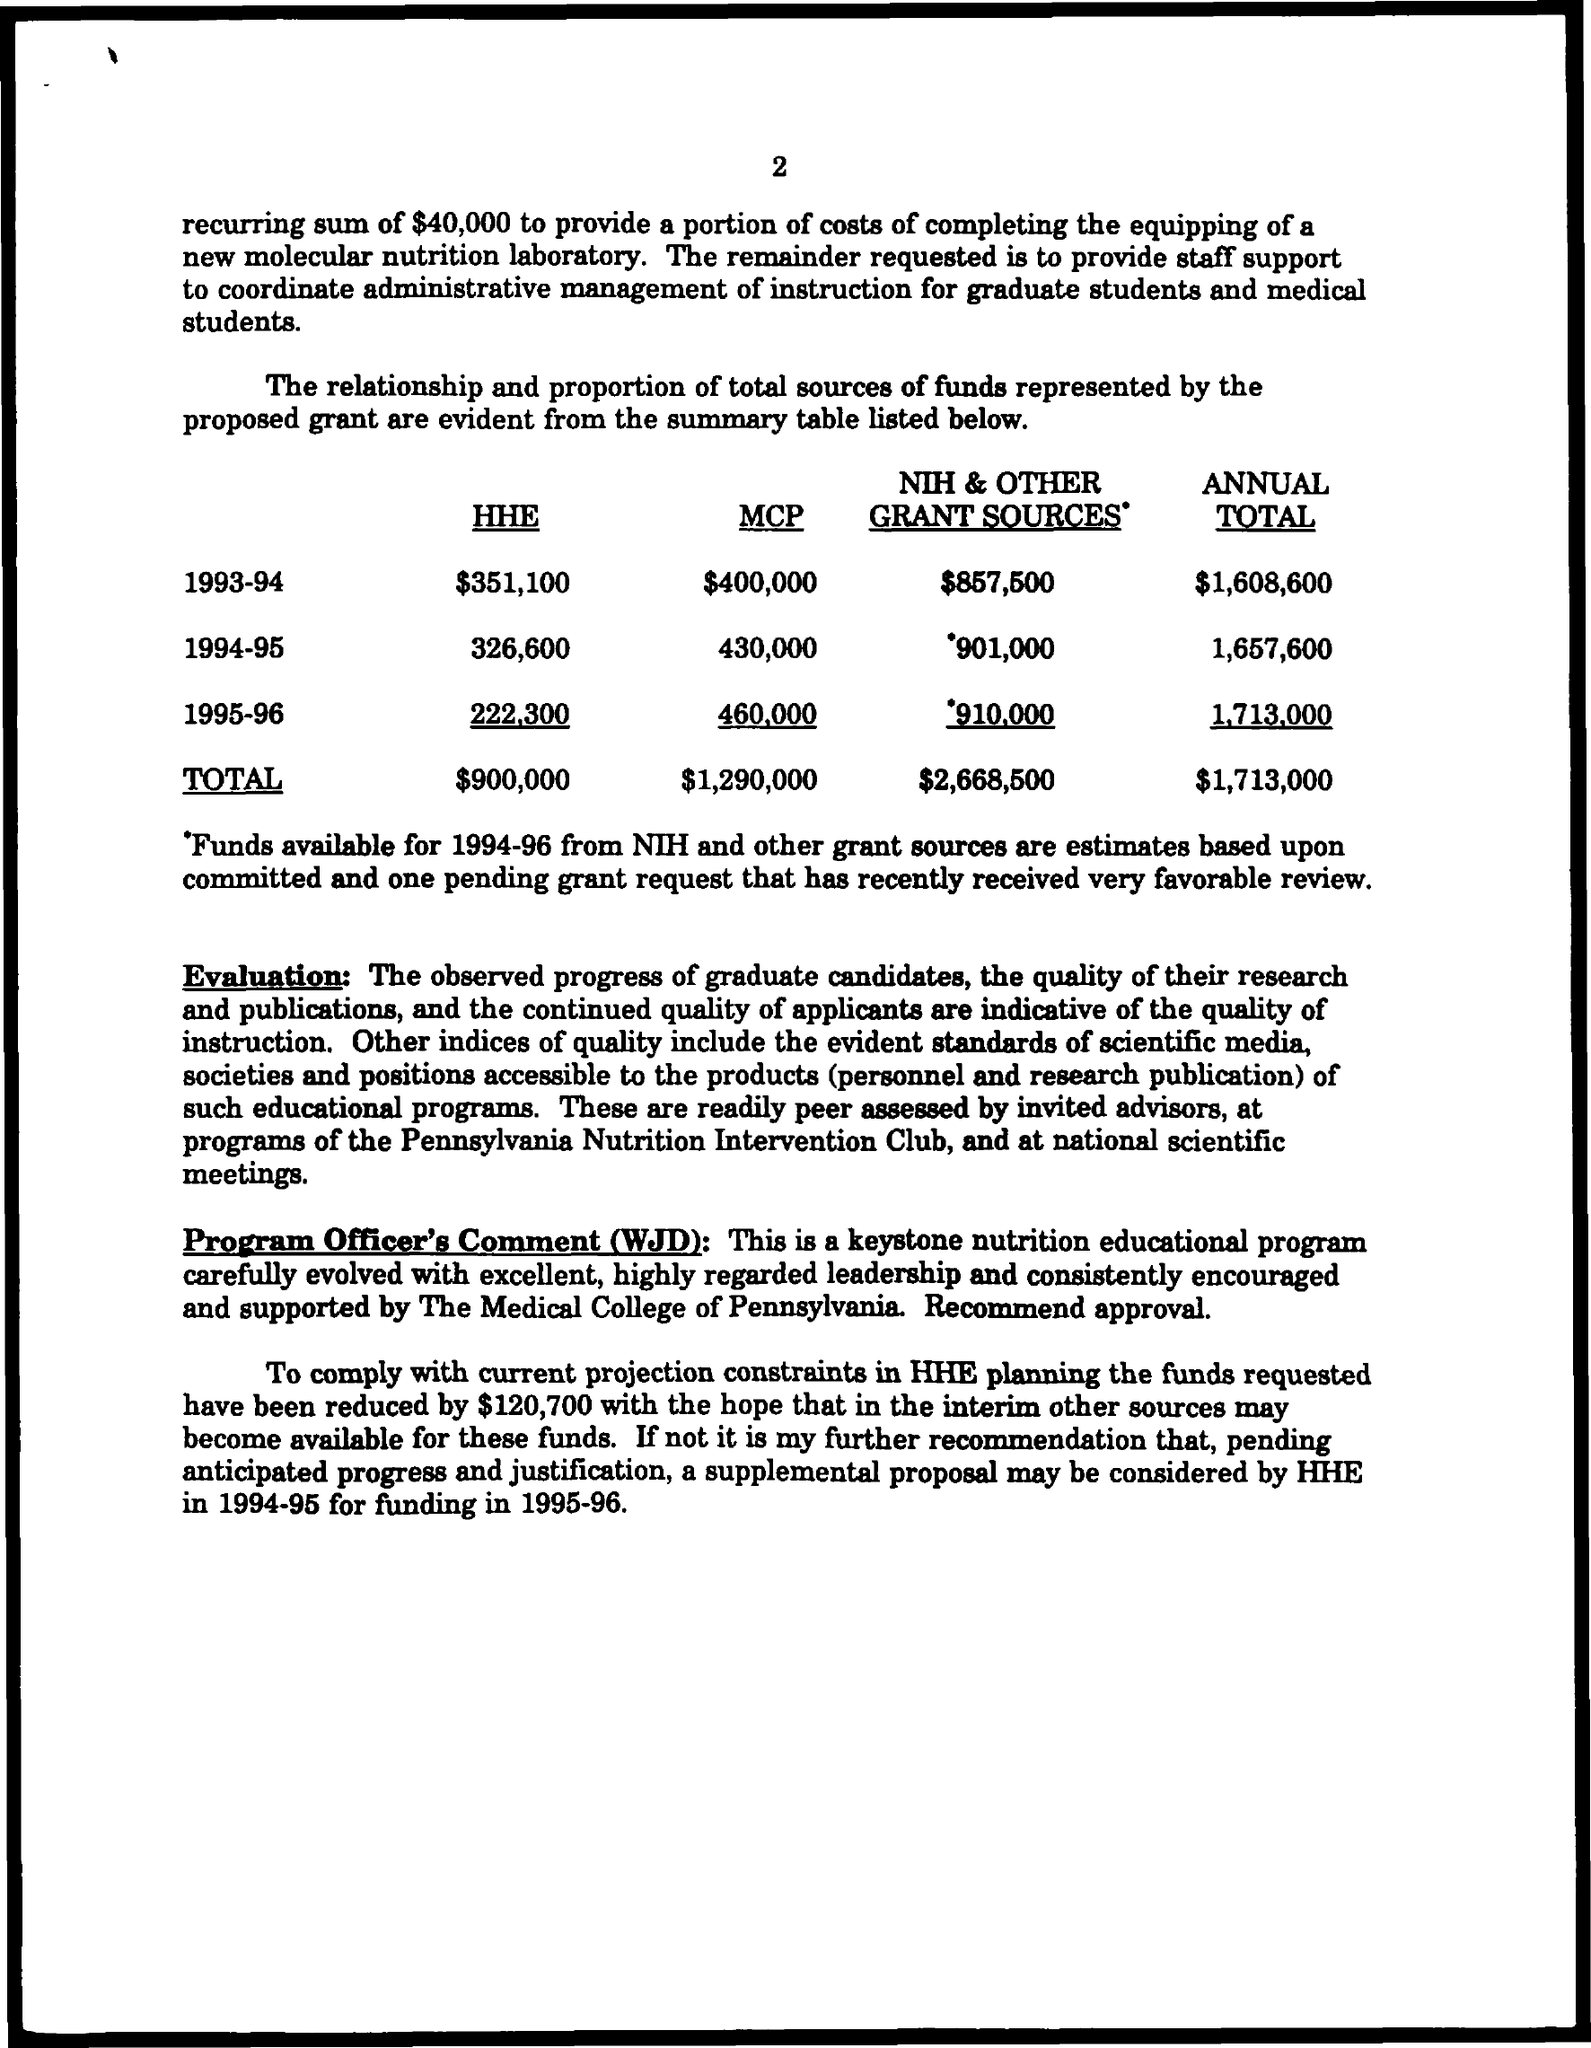What is the page number?
Ensure brevity in your answer.  2. What is the annual total in the year 1993-94?
Ensure brevity in your answer.  $1,608,600. What is the annual total in the year 1994-95?
Your response must be concise. 1,657,600. What is the annual total in the year 1995-96?
Keep it short and to the point. 1,713,000. What is the HHE in the year 1993-94?
Your answer should be compact. $351,100. What is the NIH & other grant sources in the year 1993-94?
Offer a terse response. $857,500. 